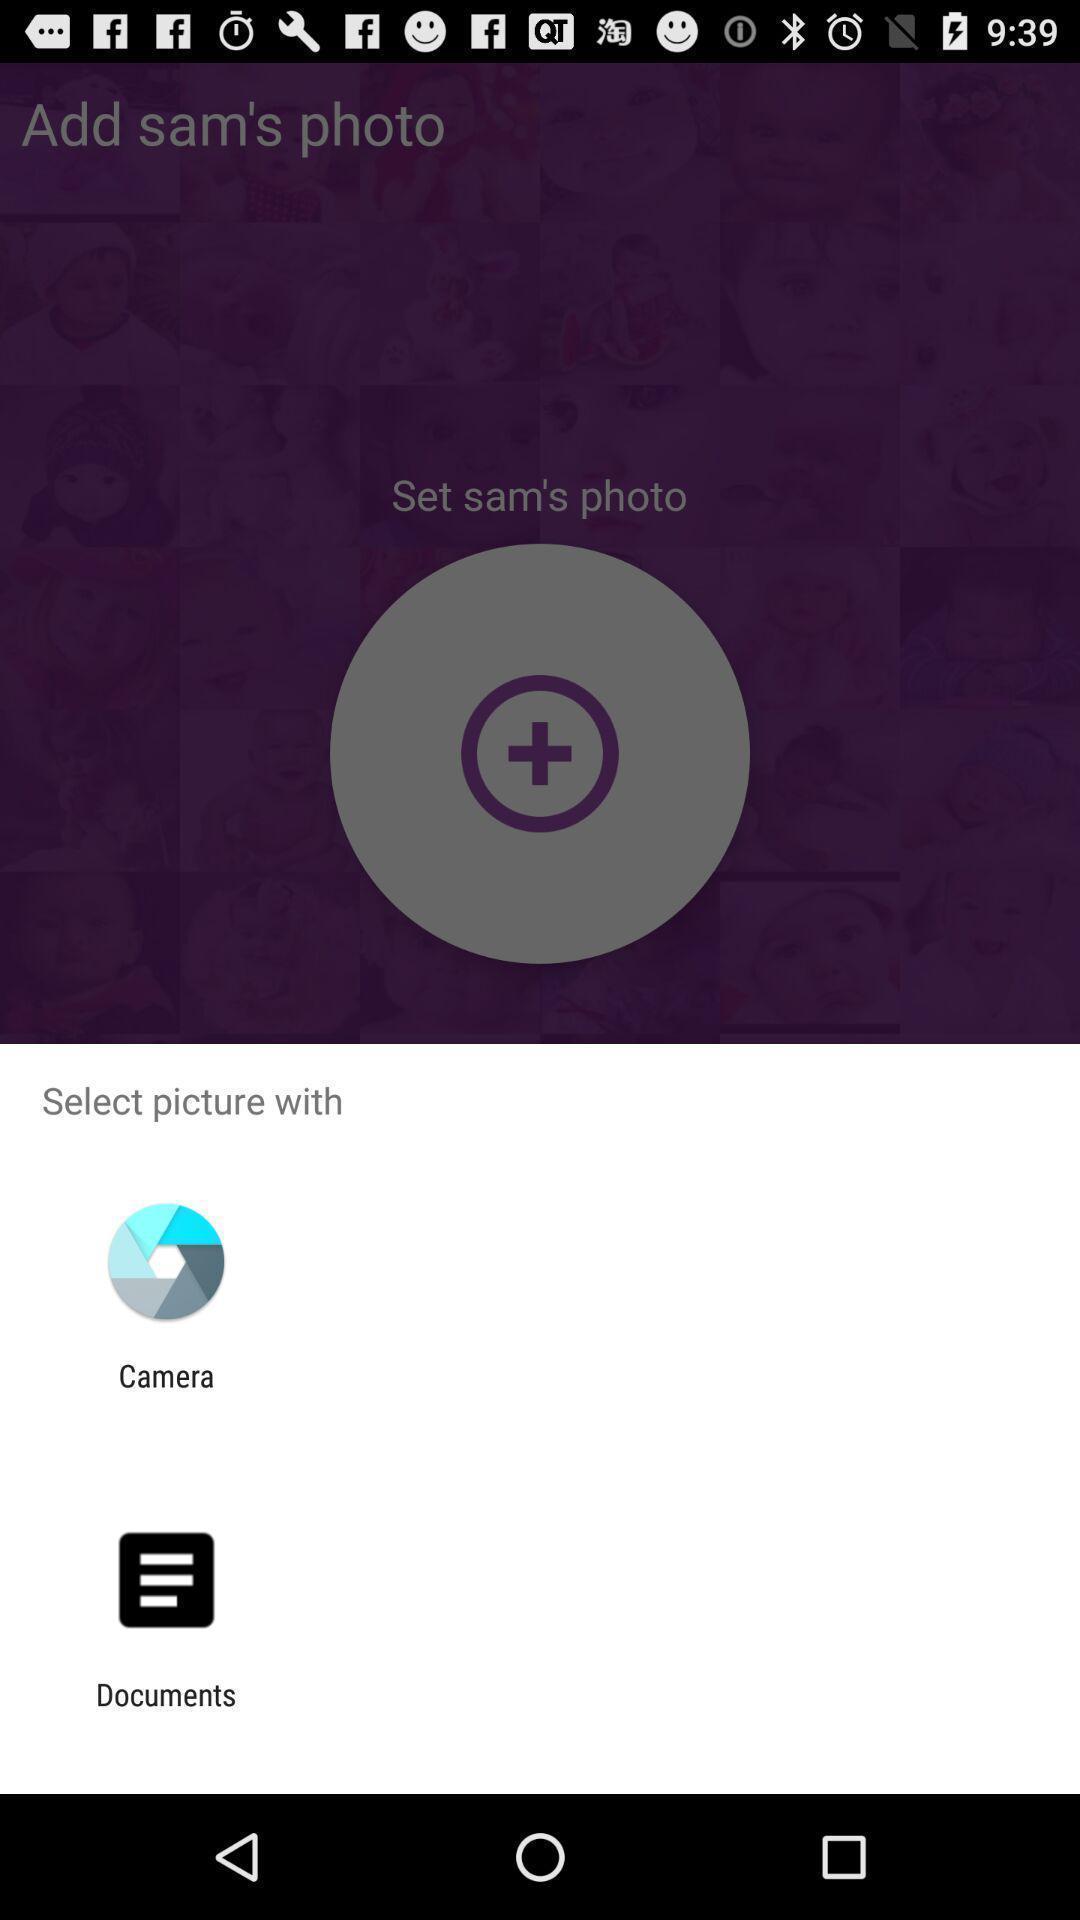Explain the elements present in this screenshot. Select picture with camera or documents. 